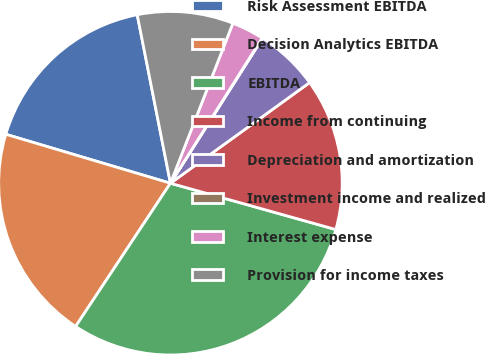<chart> <loc_0><loc_0><loc_500><loc_500><pie_chart><fcel>Risk Assessment EBITDA<fcel>Decision Analytics EBITDA<fcel>EBITDA<fcel>Income from continuing<fcel>Depreciation and amortization<fcel>Investment income and realized<fcel>Interest expense<fcel>Provision for income taxes<nl><fcel>17.3%<fcel>20.29%<fcel>29.96%<fcel>14.31%<fcel>6.03%<fcel>0.04%<fcel>3.04%<fcel>9.02%<nl></chart> 